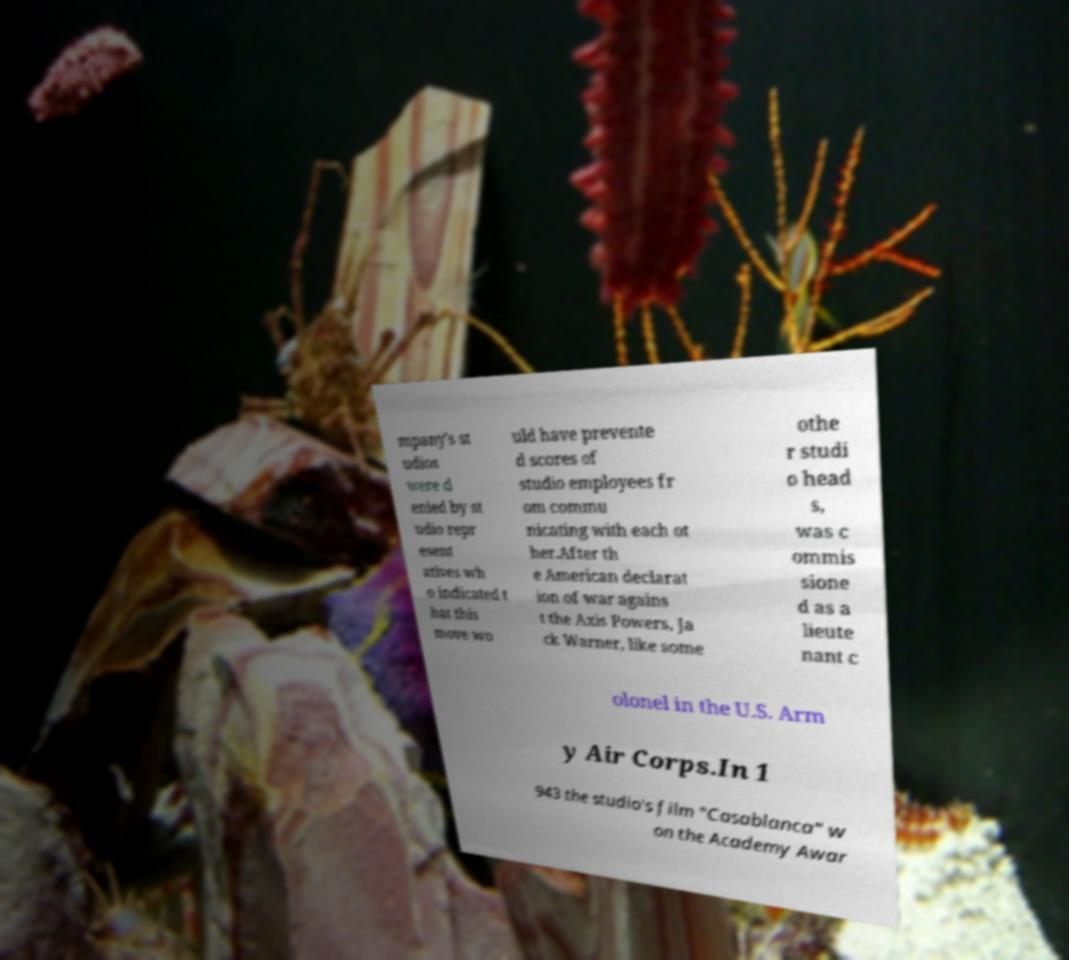I need the written content from this picture converted into text. Can you do that? mpany's st udios were d enied by st udio repr esent atives wh o indicated t hat this move wo uld have prevente d scores of studio employees fr om commu nicating with each ot her.After th e American declarat ion of war agains t the Axis Powers, Ja ck Warner, like some othe r studi o head s, was c ommis sione d as a lieute nant c olonel in the U.S. Arm y Air Corps.In 1 943 the studio's film "Casablanca" w on the Academy Awar 